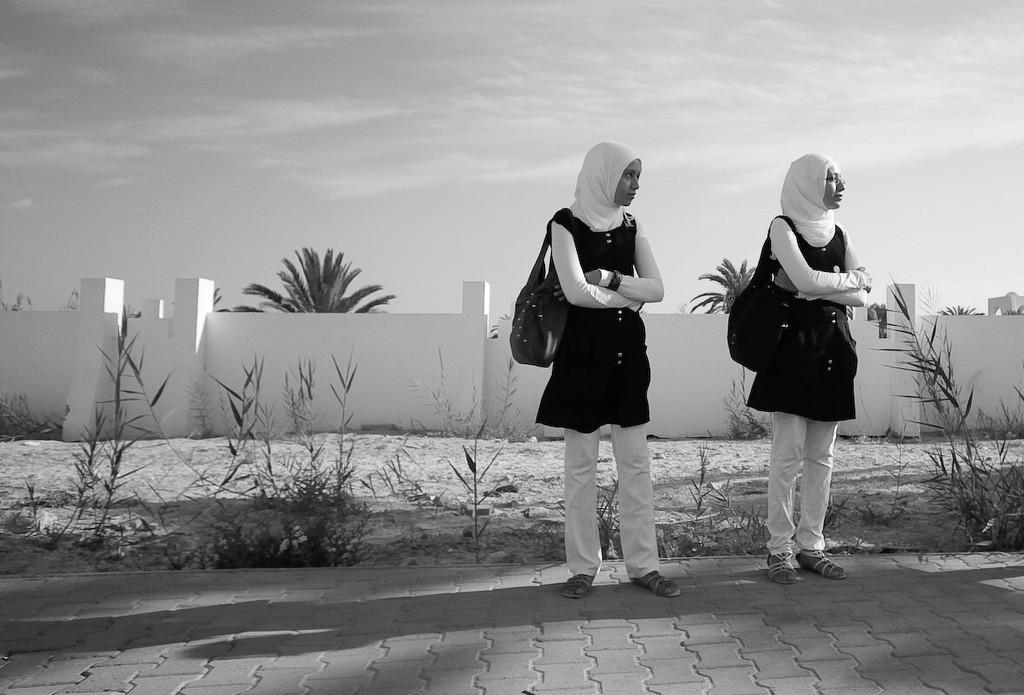How many people are in the image? There are two girls in the image. Where are the girls located in the image? The girls are on the right side of the image. What can be seen in the background of the image? There is a wall in the background of the image, and behind the wall, there are trees. What year is depicted in the image? The image does not depict a specific year; it is a photograph of two girls in a location with a wall and trees. Are there any slaves present in the image? There is no indication of any slaves in the image; it features two girls in a location with a wall and trees. 